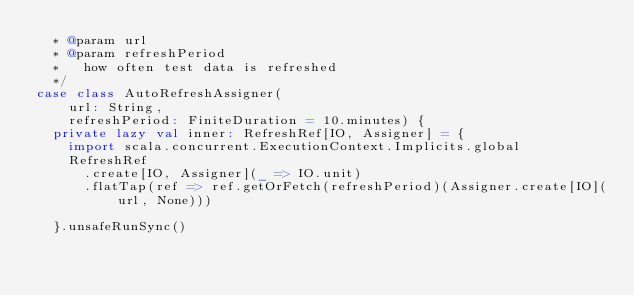Convert code to text. <code><loc_0><loc_0><loc_500><loc_500><_Scala_>  * @param url
  * @param refreshPeriod
  *   how often test data is refreshed
  */
case class AutoRefreshAssigner(
    url: String,
    refreshPeriod: FiniteDuration = 10.minutes) {
  private lazy val inner: RefreshRef[IO, Assigner] = {
    import scala.concurrent.ExecutionContext.Implicits.global
    RefreshRef
      .create[IO, Assigner](_ => IO.unit)
      .flatTap(ref => ref.getOrFetch(refreshPeriod)(Assigner.create[IO](url, None)))

  }.unsafeRunSync()
</code> 